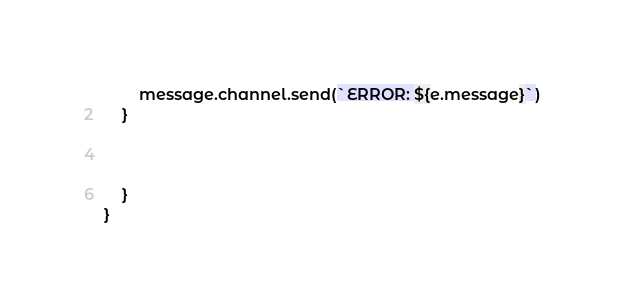Convert code to text. <code><loc_0><loc_0><loc_500><loc_500><_JavaScript_>        message.channel.send(`ERROR: ${e.message}`)
    }
    


    }
}</code> 